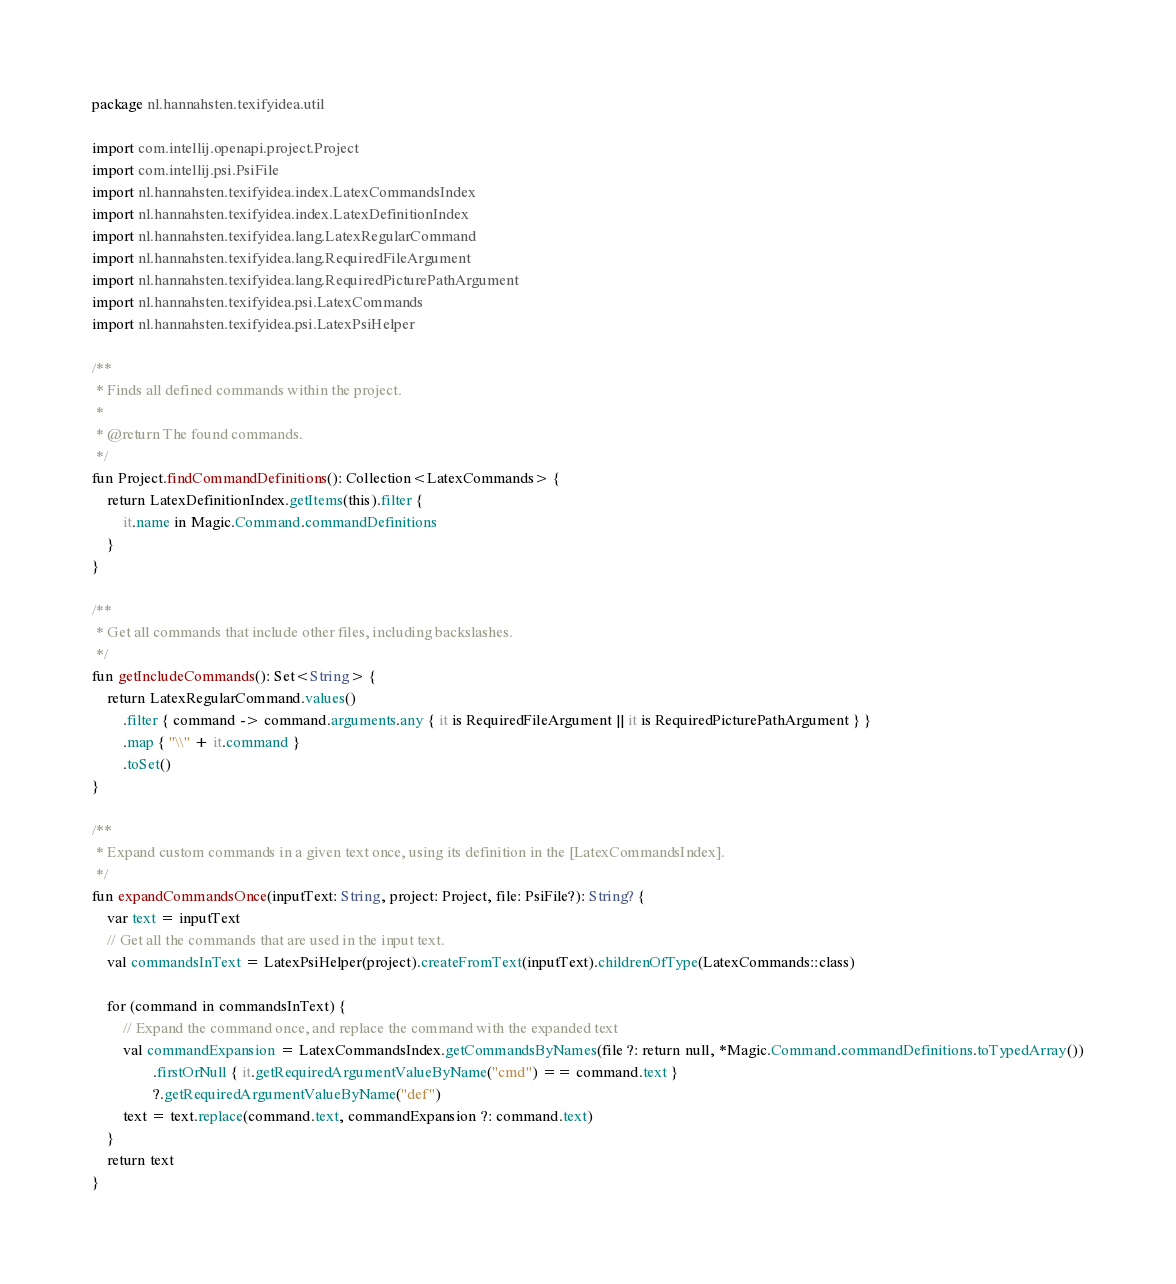Convert code to text. <code><loc_0><loc_0><loc_500><loc_500><_Kotlin_>package nl.hannahsten.texifyidea.util

import com.intellij.openapi.project.Project
import com.intellij.psi.PsiFile
import nl.hannahsten.texifyidea.index.LatexCommandsIndex
import nl.hannahsten.texifyidea.index.LatexDefinitionIndex
import nl.hannahsten.texifyidea.lang.LatexRegularCommand
import nl.hannahsten.texifyidea.lang.RequiredFileArgument
import nl.hannahsten.texifyidea.lang.RequiredPicturePathArgument
import nl.hannahsten.texifyidea.psi.LatexCommands
import nl.hannahsten.texifyidea.psi.LatexPsiHelper

/**
 * Finds all defined commands within the project.
 *
 * @return The found commands.
 */
fun Project.findCommandDefinitions(): Collection<LatexCommands> {
    return LatexDefinitionIndex.getItems(this).filter {
        it.name in Magic.Command.commandDefinitions
    }
}

/**
 * Get all commands that include other files, including backslashes.
 */
fun getIncludeCommands(): Set<String> {
    return LatexRegularCommand.values()
        .filter { command -> command.arguments.any { it is RequiredFileArgument || it is RequiredPicturePathArgument } }
        .map { "\\" + it.command }
        .toSet()
}

/**
 * Expand custom commands in a given text once, using its definition in the [LatexCommandsIndex].
 */
fun expandCommandsOnce(inputText: String, project: Project, file: PsiFile?): String? {
    var text = inputText
    // Get all the commands that are used in the input text.
    val commandsInText = LatexPsiHelper(project).createFromText(inputText).childrenOfType(LatexCommands::class)

    for (command in commandsInText) {
        // Expand the command once, and replace the command with the expanded text
        val commandExpansion = LatexCommandsIndex.getCommandsByNames(file ?: return null, *Magic.Command.commandDefinitions.toTypedArray())
                .firstOrNull { it.getRequiredArgumentValueByName("cmd") == command.text }
                ?.getRequiredArgumentValueByName("def")
        text = text.replace(command.text, commandExpansion ?: command.text)
    }
    return text
}
</code> 